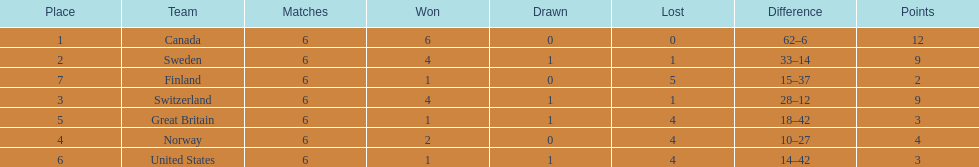How many teams won only 1 match? 3. 